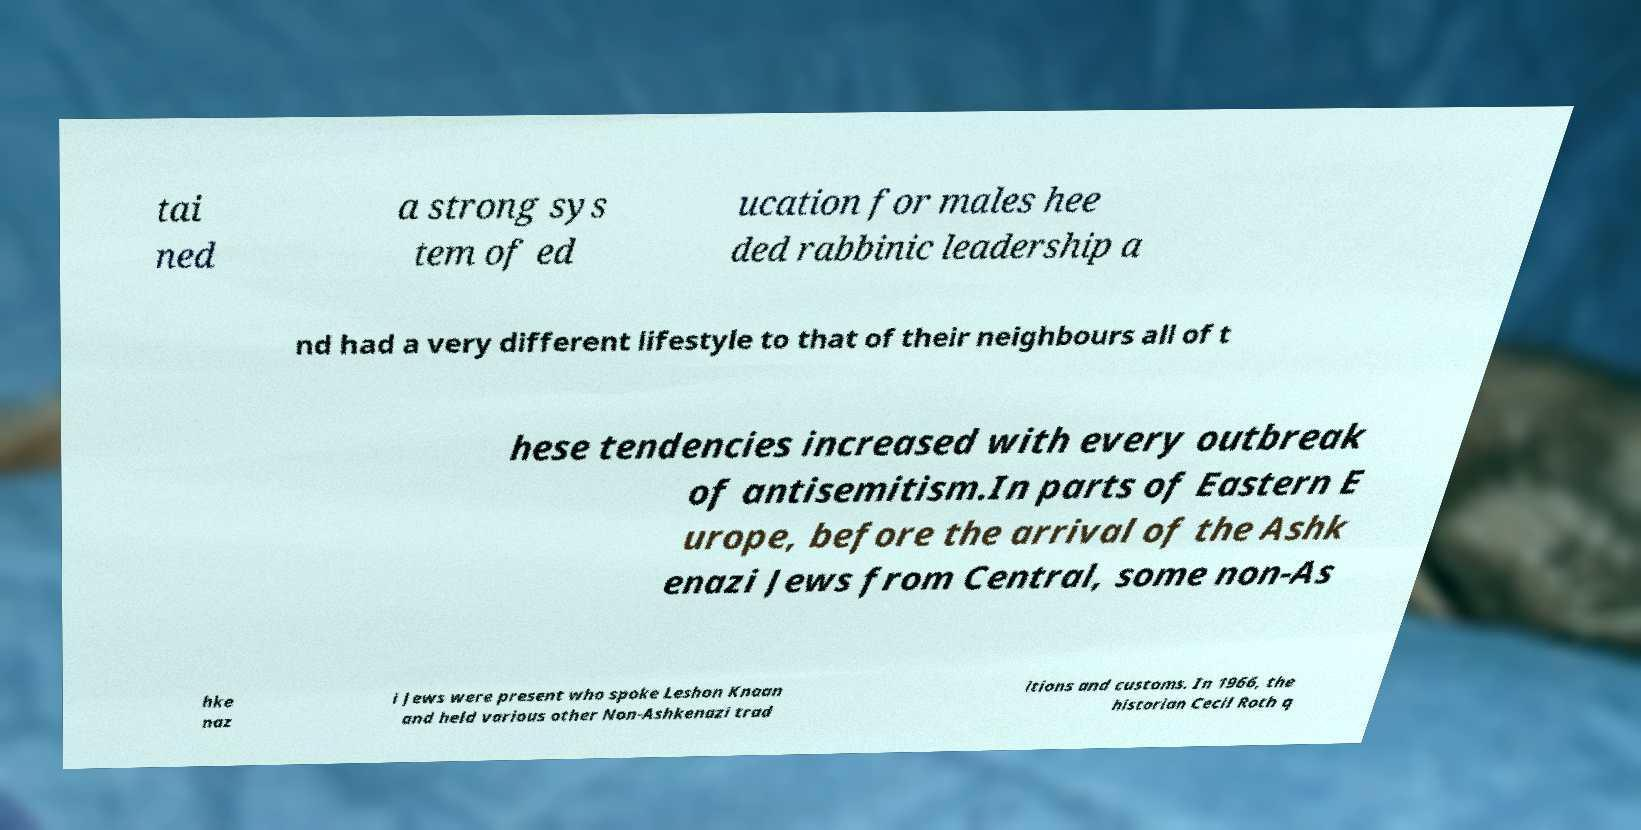Could you assist in decoding the text presented in this image and type it out clearly? tai ned a strong sys tem of ed ucation for males hee ded rabbinic leadership a nd had a very different lifestyle to that of their neighbours all of t hese tendencies increased with every outbreak of antisemitism.In parts of Eastern E urope, before the arrival of the Ashk enazi Jews from Central, some non-As hke naz i Jews were present who spoke Leshon Knaan and held various other Non-Ashkenazi trad itions and customs. In 1966, the historian Cecil Roth q 